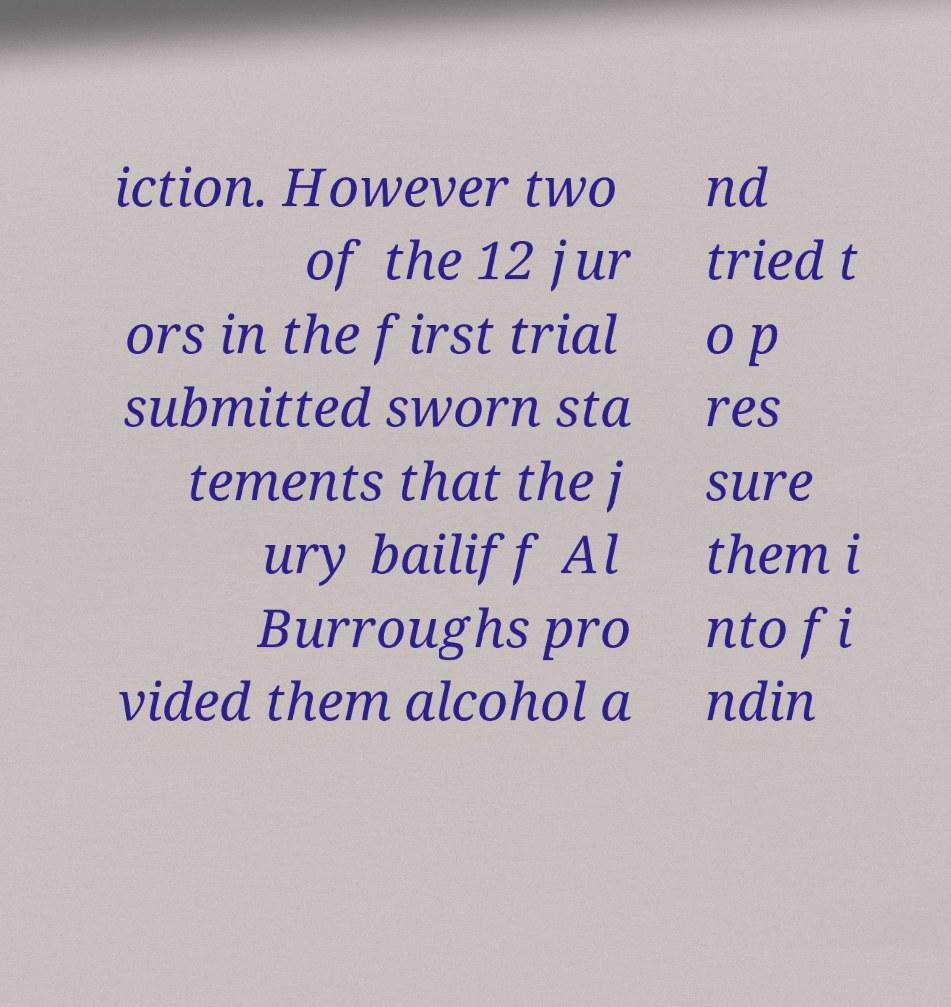Could you extract and type out the text from this image? iction. However two of the 12 jur ors in the first trial submitted sworn sta tements that the j ury bailiff Al Burroughs pro vided them alcohol a nd tried t o p res sure them i nto fi ndin 